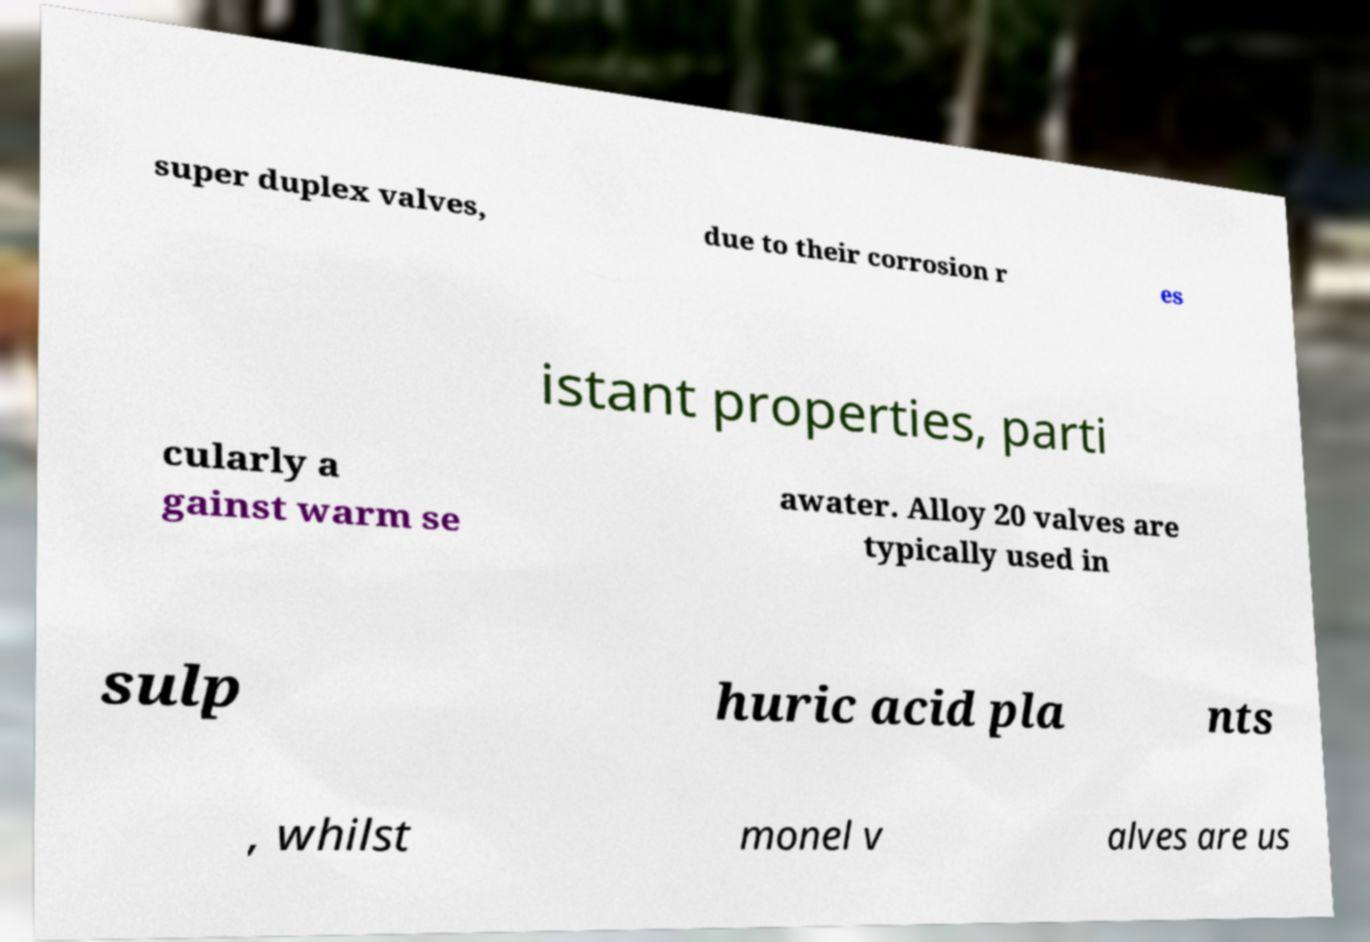Please identify and transcribe the text found in this image. super duplex valves, due to their corrosion r es istant properties, parti cularly a gainst warm se awater. Alloy 20 valves are typically used in sulp huric acid pla nts , whilst monel v alves are us 